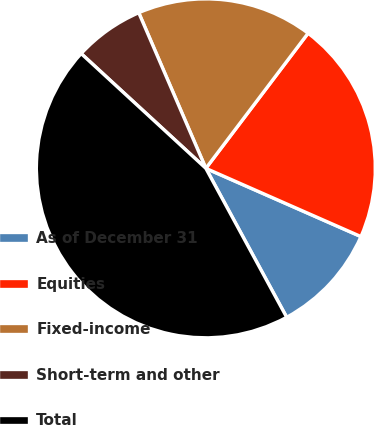<chart> <loc_0><loc_0><loc_500><loc_500><pie_chart><fcel>As of December 31<fcel>Equities<fcel>Fixed-income<fcel>Short-term and other<fcel>Total<nl><fcel>10.49%<fcel>21.29%<fcel>16.79%<fcel>6.68%<fcel>44.76%<nl></chart> 